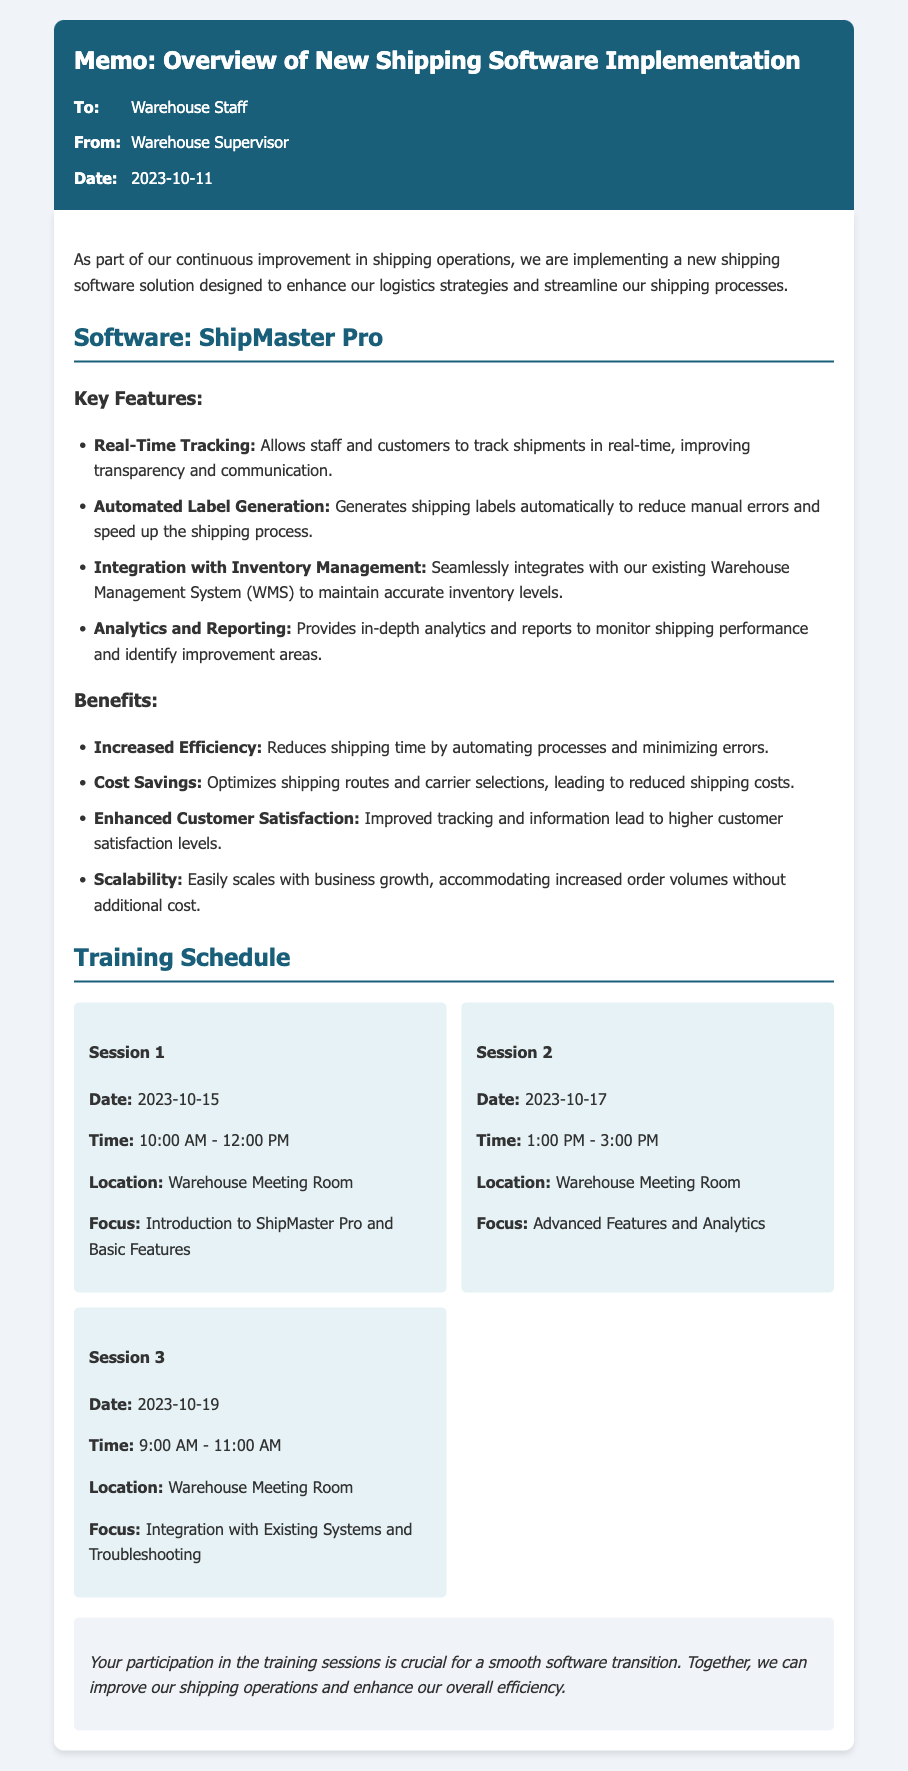What is the name of the new shipping software? The new shipping software implemented is mentioned as ShipMaster Pro in the document.
Answer: ShipMaster Pro What is the date of the first training session? The date of the first training session is specifically listed in the training schedule section as 2023-10-15.
Answer: 2023-10-15 How long is the second training session scheduled to last? The time duration of the second training session is specified as 1:00 PM to 3:00 PM, which is 2 hours long.
Answer: 2 hours What key feature minimizes manual errors? The document lists Automated Label Generation as a key feature that reduces manual errors in the shipping process.
Answer: Automated Label Generation Which benefit is related to reducing shipping costs? Cost Savings is identified as a benefit that optimizes shipping routes and selections, leading to reduced shipping costs.
Answer: Cost Savings What is the focus of the third training session? The focus of the third training session is clearly stated in the memo as Integration with Existing Systems and Troubleshooting.
Answer: Integration with Existing Systems and Troubleshooting How many training sessions are outlined in the memo? The memo outlines a total of three training sessions in the training schedule section.
Answer: Three When is the second training session scheduled to take place? The memo provides the date for the second session as 2023-10-17, detailing it within the training schedule.
Answer: 2023-10-17 What aspect of the software does Real-Time Tracking improve? Real-Time Tracking helps improve transparency and communication, as explained in the key features section.
Answer: Transparency and communication 